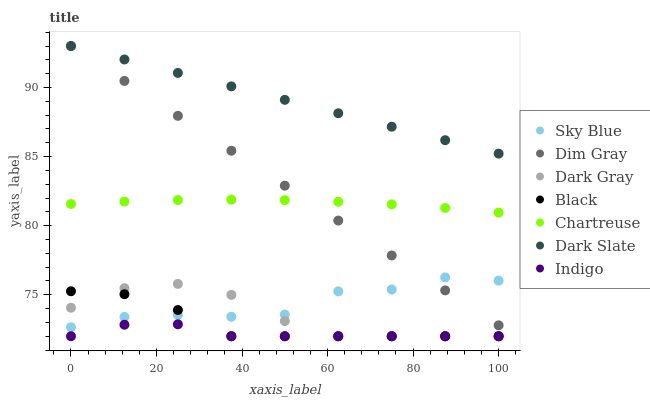Does Indigo have the minimum area under the curve?
Answer yes or no. Yes. Does Dark Slate have the maximum area under the curve?
Answer yes or no. Yes. Does Dark Gray have the minimum area under the curve?
Answer yes or no. No. Does Dark Gray have the maximum area under the curve?
Answer yes or no. No. Is Dark Slate the smoothest?
Answer yes or no. Yes. Is Sky Blue the roughest?
Answer yes or no. Yes. Is Indigo the smoothest?
Answer yes or no. No. Is Indigo the roughest?
Answer yes or no. No. Does Indigo have the lowest value?
Answer yes or no. Yes. Does Dark Slate have the lowest value?
Answer yes or no. No. Does Dark Slate have the highest value?
Answer yes or no. Yes. Does Dark Gray have the highest value?
Answer yes or no. No. Is Sky Blue less than Dark Slate?
Answer yes or no. Yes. Is Chartreuse greater than Dark Gray?
Answer yes or no. Yes. Does Sky Blue intersect Dark Gray?
Answer yes or no. Yes. Is Sky Blue less than Dark Gray?
Answer yes or no. No. Is Sky Blue greater than Dark Gray?
Answer yes or no. No. Does Sky Blue intersect Dark Slate?
Answer yes or no. No. 